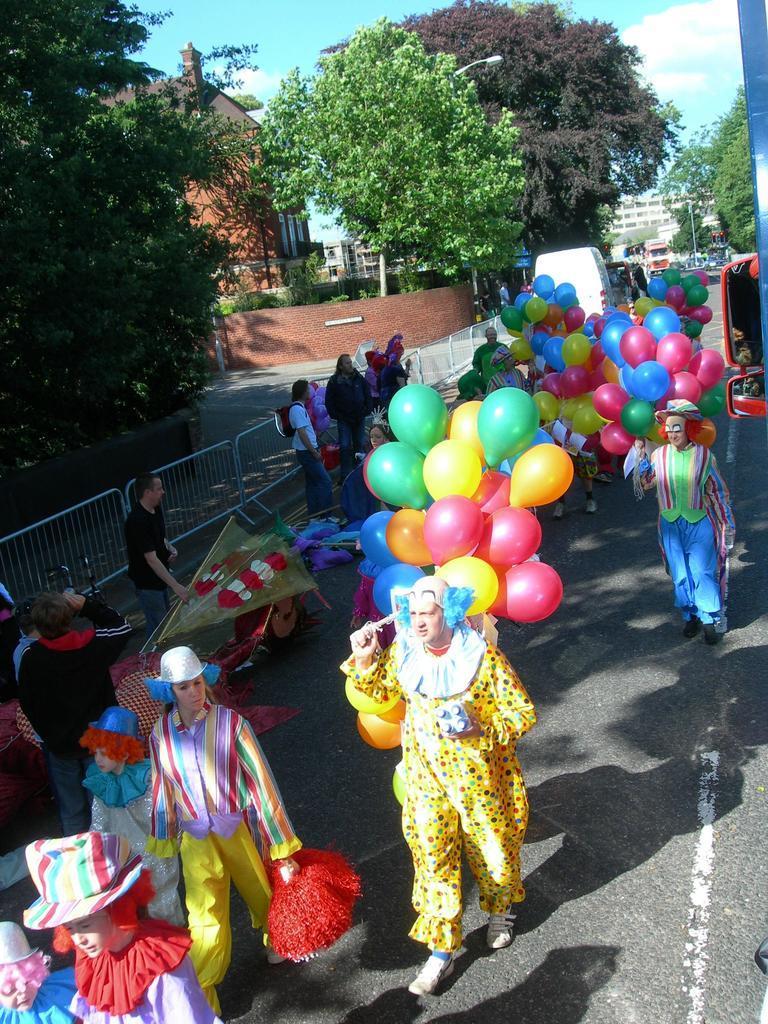Describe this image in one or two sentences. Few people are walking and few people are standing and these two people holding balloons and this person holding an object. We can see fence. In the background we can see trees,buildings,light,vehicles and sky. 